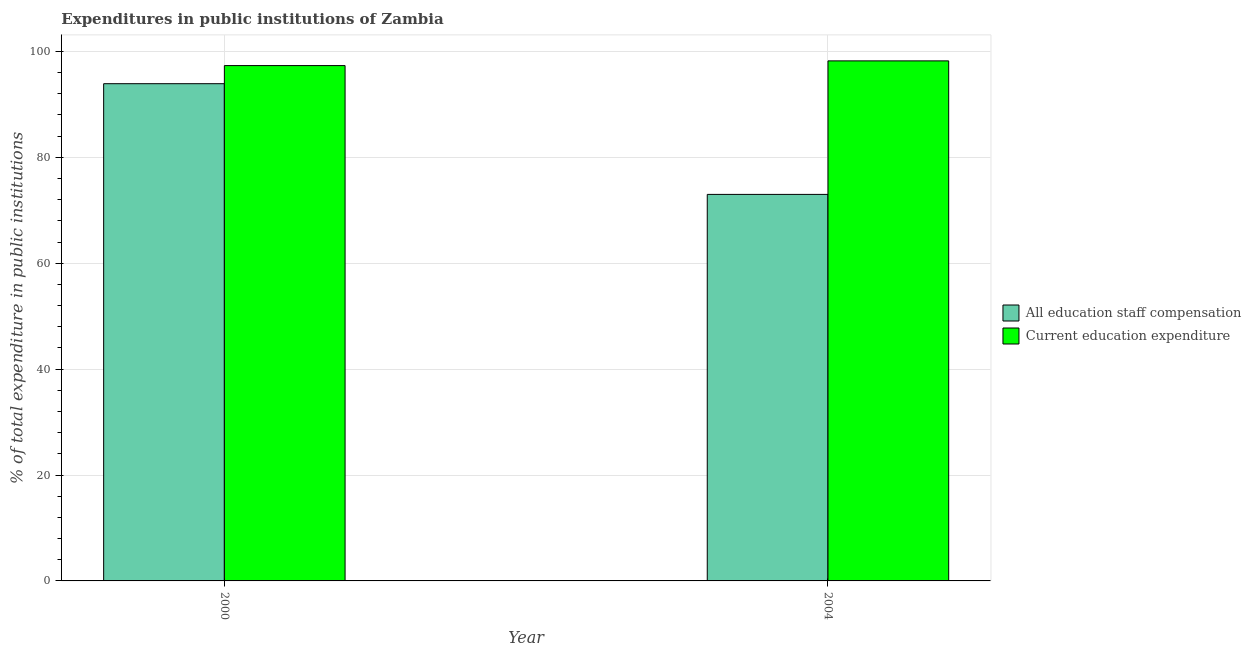How many different coloured bars are there?
Your response must be concise. 2. How many groups of bars are there?
Provide a short and direct response. 2. How many bars are there on the 1st tick from the left?
Offer a very short reply. 2. How many bars are there on the 1st tick from the right?
Give a very brief answer. 2. In how many cases, is the number of bars for a given year not equal to the number of legend labels?
Make the answer very short. 0. What is the expenditure in education in 2000?
Make the answer very short. 97.32. Across all years, what is the maximum expenditure in education?
Your response must be concise. 98.21. Across all years, what is the minimum expenditure in staff compensation?
Make the answer very short. 72.99. In which year was the expenditure in staff compensation maximum?
Your answer should be compact. 2000. In which year was the expenditure in staff compensation minimum?
Offer a very short reply. 2004. What is the total expenditure in education in the graph?
Provide a succinct answer. 195.52. What is the difference between the expenditure in staff compensation in 2000 and that in 2004?
Give a very brief answer. 20.9. What is the difference between the expenditure in staff compensation in 2000 and the expenditure in education in 2004?
Your answer should be very brief. 20.9. What is the average expenditure in education per year?
Your answer should be compact. 97.76. In the year 2004, what is the difference between the expenditure in staff compensation and expenditure in education?
Your response must be concise. 0. In how many years, is the expenditure in staff compensation greater than 52 %?
Keep it short and to the point. 2. What is the ratio of the expenditure in education in 2000 to that in 2004?
Provide a short and direct response. 0.99. In how many years, is the expenditure in staff compensation greater than the average expenditure in staff compensation taken over all years?
Make the answer very short. 1. What does the 2nd bar from the left in 2000 represents?
Offer a terse response. Current education expenditure. What does the 2nd bar from the right in 2004 represents?
Offer a very short reply. All education staff compensation. How many years are there in the graph?
Ensure brevity in your answer.  2. Are the values on the major ticks of Y-axis written in scientific E-notation?
Offer a very short reply. No. Does the graph contain grids?
Provide a short and direct response. Yes. Where does the legend appear in the graph?
Your answer should be very brief. Center right. How many legend labels are there?
Give a very brief answer. 2. What is the title of the graph?
Ensure brevity in your answer.  Expenditures in public institutions of Zambia. What is the label or title of the Y-axis?
Ensure brevity in your answer.  % of total expenditure in public institutions. What is the % of total expenditure in public institutions of All education staff compensation in 2000?
Ensure brevity in your answer.  93.9. What is the % of total expenditure in public institutions in Current education expenditure in 2000?
Provide a short and direct response. 97.32. What is the % of total expenditure in public institutions of All education staff compensation in 2004?
Provide a succinct answer. 72.99. What is the % of total expenditure in public institutions of Current education expenditure in 2004?
Your answer should be compact. 98.21. Across all years, what is the maximum % of total expenditure in public institutions of All education staff compensation?
Your response must be concise. 93.9. Across all years, what is the maximum % of total expenditure in public institutions of Current education expenditure?
Keep it short and to the point. 98.21. Across all years, what is the minimum % of total expenditure in public institutions of All education staff compensation?
Your answer should be compact. 72.99. Across all years, what is the minimum % of total expenditure in public institutions in Current education expenditure?
Provide a short and direct response. 97.32. What is the total % of total expenditure in public institutions of All education staff compensation in the graph?
Ensure brevity in your answer.  166.89. What is the total % of total expenditure in public institutions of Current education expenditure in the graph?
Offer a terse response. 195.52. What is the difference between the % of total expenditure in public institutions in All education staff compensation in 2000 and that in 2004?
Offer a very short reply. 20.9. What is the difference between the % of total expenditure in public institutions in Current education expenditure in 2000 and that in 2004?
Give a very brief answer. -0.89. What is the difference between the % of total expenditure in public institutions of All education staff compensation in 2000 and the % of total expenditure in public institutions of Current education expenditure in 2004?
Your response must be concise. -4.31. What is the average % of total expenditure in public institutions of All education staff compensation per year?
Provide a succinct answer. 83.44. What is the average % of total expenditure in public institutions in Current education expenditure per year?
Offer a terse response. 97.76. In the year 2000, what is the difference between the % of total expenditure in public institutions of All education staff compensation and % of total expenditure in public institutions of Current education expenditure?
Provide a succinct answer. -3.42. In the year 2004, what is the difference between the % of total expenditure in public institutions in All education staff compensation and % of total expenditure in public institutions in Current education expenditure?
Offer a very short reply. -25.21. What is the ratio of the % of total expenditure in public institutions in All education staff compensation in 2000 to that in 2004?
Offer a very short reply. 1.29. What is the ratio of the % of total expenditure in public institutions in Current education expenditure in 2000 to that in 2004?
Ensure brevity in your answer.  0.99. What is the difference between the highest and the second highest % of total expenditure in public institutions in All education staff compensation?
Keep it short and to the point. 20.9. What is the difference between the highest and the second highest % of total expenditure in public institutions of Current education expenditure?
Your answer should be very brief. 0.89. What is the difference between the highest and the lowest % of total expenditure in public institutions of All education staff compensation?
Provide a succinct answer. 20.9. What is the difference between the highest and the lowest % of total expenditure in public institutions in Current education expenditure?
Offer a very short reply. 0.89. 